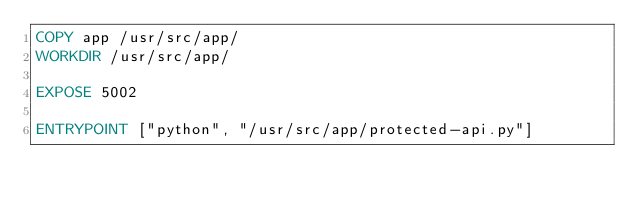<code> <loc_0><loc_0><loc_500><loc_500><_Dockerfile_>COPY app /usr/src/app/
WORKDIR /usr/src/app/

EXPOSE 5002

ENTRYPOINT ["python", "/usr/src/app/protected-api.py"]
</code> 